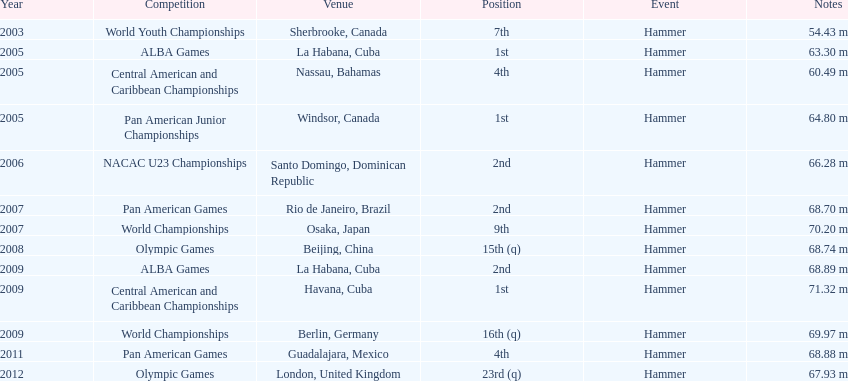Is arasay thondike's count of 1st place tournament triumphs more/less than 4? Less. Can you parse all the data within this table? {'header': ['Year', 'Competition', 'Venue', 'Position', 'Event', 'Notes'], 'rows': [['2003', 'World Youth Championships', 'Sherbrooke, Canada', '7th', 'Hammer', '54.43 m'], ['2005', 'ALBA Games', 'La Habana, Cuba', '1st', 'Hammer', '63.30 m'], ['2005', 'Central American and Caribbean Championships', 'Nassau, Bahamas', '4th', 'Hammer', '60.49 m'], ['2005', 'Pan American Junior Championships', 'Windsor, Canada', '1st', 'Hammer', '64.80 m'], ['2006', 'NACAC U23 Championships', 'Santo Domingo, Dominican Republic', '2nd', 'Hammer', '66.28 m'], ['2007', 'Pan American Games', 'Rio de Janeiro, Brazil', '2nd', 'Hammer', '68.70 m'], ['2007', 'World Championships', 'Osaka, Japan', '9th', 'Hammer', '70.20 m'], ['2008', 'Olympic Games', 'Beijing, China', '15th (q)', 'Hammer', '68.74 m'], ['2009', 'ALBA Games', 'La Habana, Cuba', '2nd', 'Hammer', '68.89 m'], ['2009', 'Central American and Caribbean Championships', 'Havana, Cuba', '1st', 'Hammer', '71.32 m'], ['2009', 'World Championships', 'Berlin, Germany', '16th (q)', 'Hammer', '69.97 m'], ['2011', 'Pan American Games', 'Guadalajara, Mexico', '4th', 'Hammer', '68.88 m'], ['2012', 'Olympic Games', 'London, United Kingdom', '23rd (q)', 'Hammer', '67.93 m']]} 